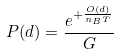Convert formula to latex. <formula><loc_0><loc_0><loc_500><loc_500>P ( d ) = \frac { e ^ { + \frac { O ( d ) } { n _ { B } T } } } { G }</formula> 